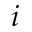Convert formula to latex. <formula><loc_0><loc_0><loc_500><loc_500>i</formula> 